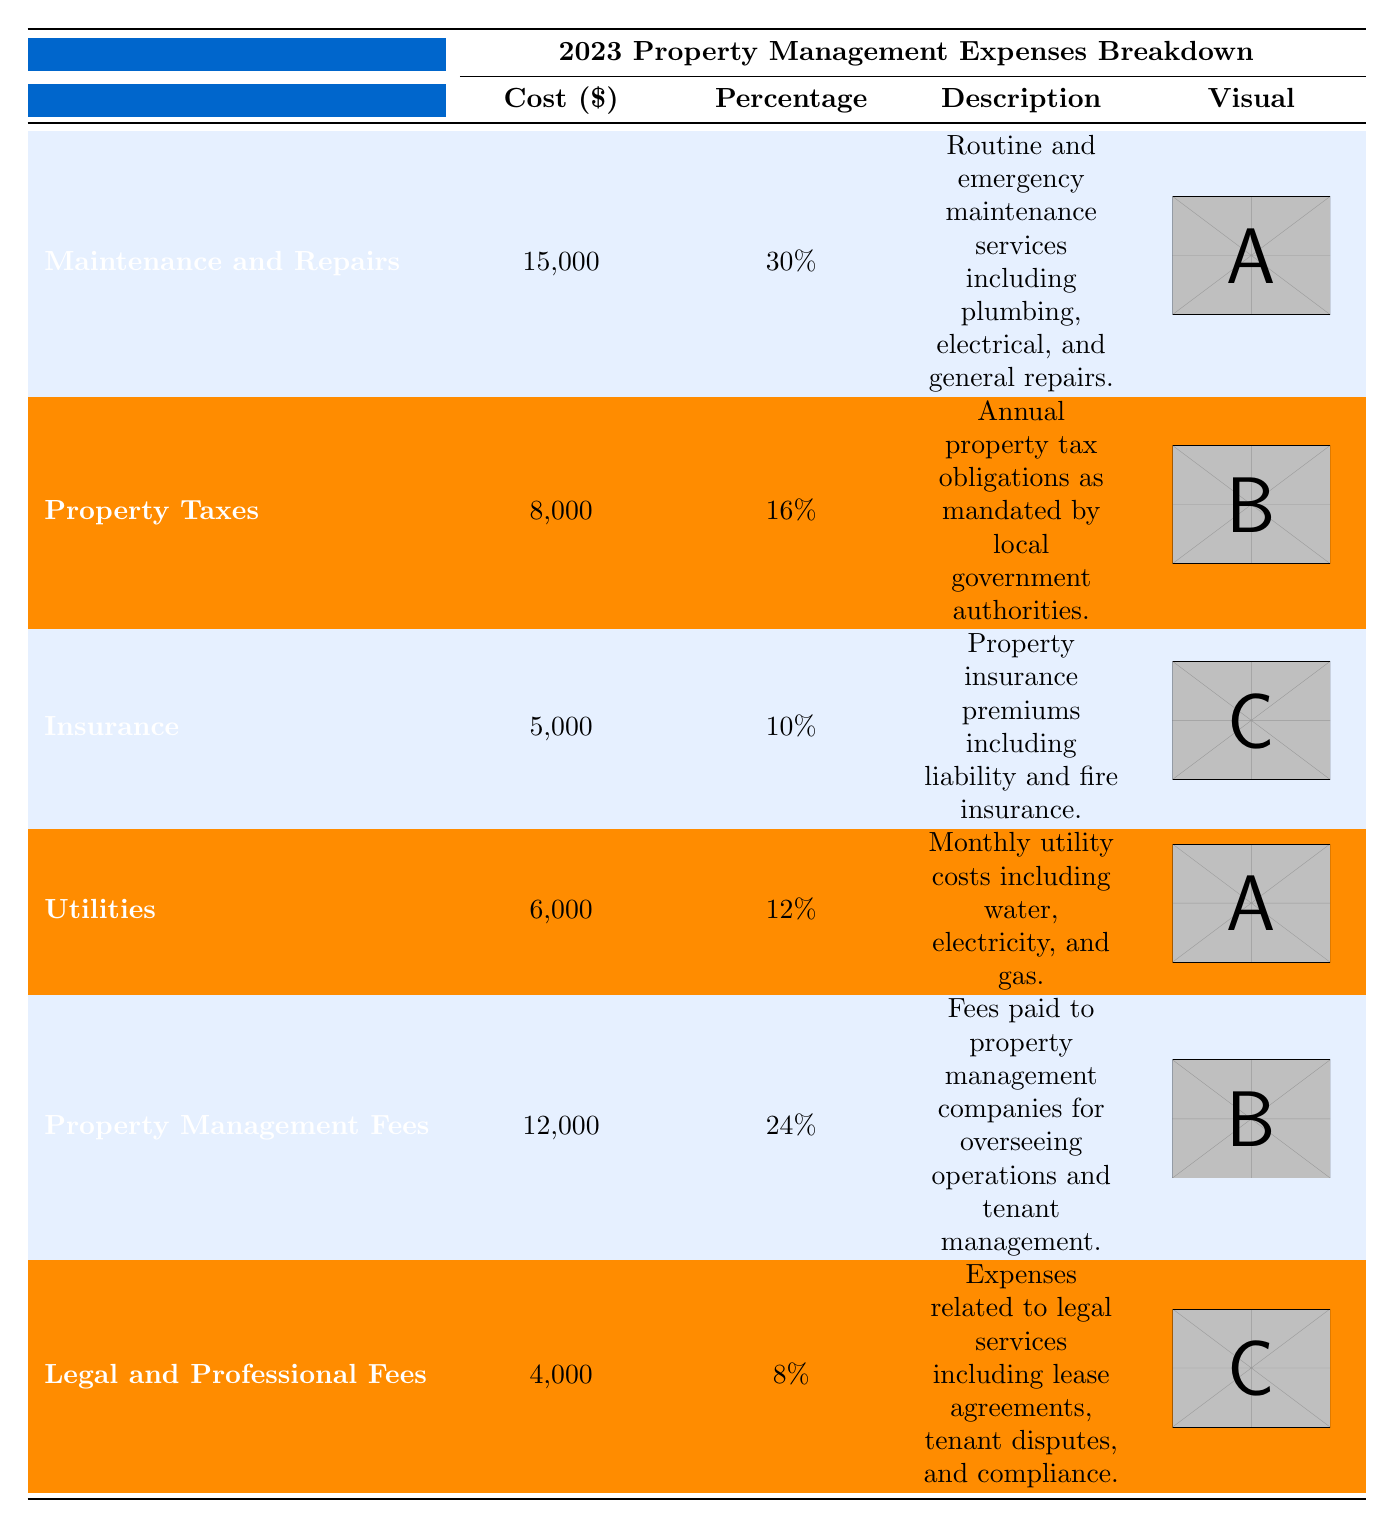What is the total cost for Maintenance and Repairs? The table shows that the cost for Maintenance and Repairs is listed as 15,000.
Answer: 15,000 What percentage of total expenses does Insurance represent? According to the table, Insurance makes up 10% of the total property management expenses.
Answer: 10% Which expense category has the highest cost? By comparing the costs in the table, Maintenance and Repairs at 15,000 has the highest cost among all categories.
Answer: Maintenance and Repairs What is the total percentage of property management fees and legal and professional fees combined? To find this, add the percentages: Property Management Fees is 24% and Legal and Professional Fees is 8%. So, 24% + 8% = 32%.
Answer: 32% Is the cost for Utilities higher than the cost for Insurance? The table states that Utilities cost 6,000 and Insurance costs 5,000. Since 6,000 is greater than 5,000, the statement is true.
Answer: Yes What is the difference in cost between Property Taxes and Legal and Professional Fees? Property Taxes cost 8,000 and Legal and Professional Fees cost 4,000. The difference is 8,000 - 4,000 = 4,000.
Answer: 4,000 What is the combined total cost of all the expense categories shown in the table? We need to sum all the costs: 15,000 (Maintenance and Repairs) + 8,000 (Property Taxes) + 5,000 (Insurance) + 6,000 (Utilities) + 12,000 (Property Management Fees) + 4,000 (Legal and Professional Fees) = 50,000.
Answer: 50,000 What is the percentage of total expenses that Maintenance and Repairs and Utilities represent together? We add the percentages of the two categories: Maintenance and Repairs (30%) and Utilities (12%). So, 30% + 12% = 42%.
Answer: 42% Which expense category has the lowest cost? From the table, we see that Legal and Professional Fees has the lowest cost of 4,000.
Answer: Legal and Professional Fees Does the total for Property Management Fees exceed the combined total of Insurance and Legal and Professional Fees? Property Management Fees is 12,000; Insurance is 5,000 and Legal and Professional Fees is 4,000. The combined total for Insurance and Legal and Professional Fees is 5,000 + 4,000 = 9,000 which is less than 12,000.
Answer: Yes 